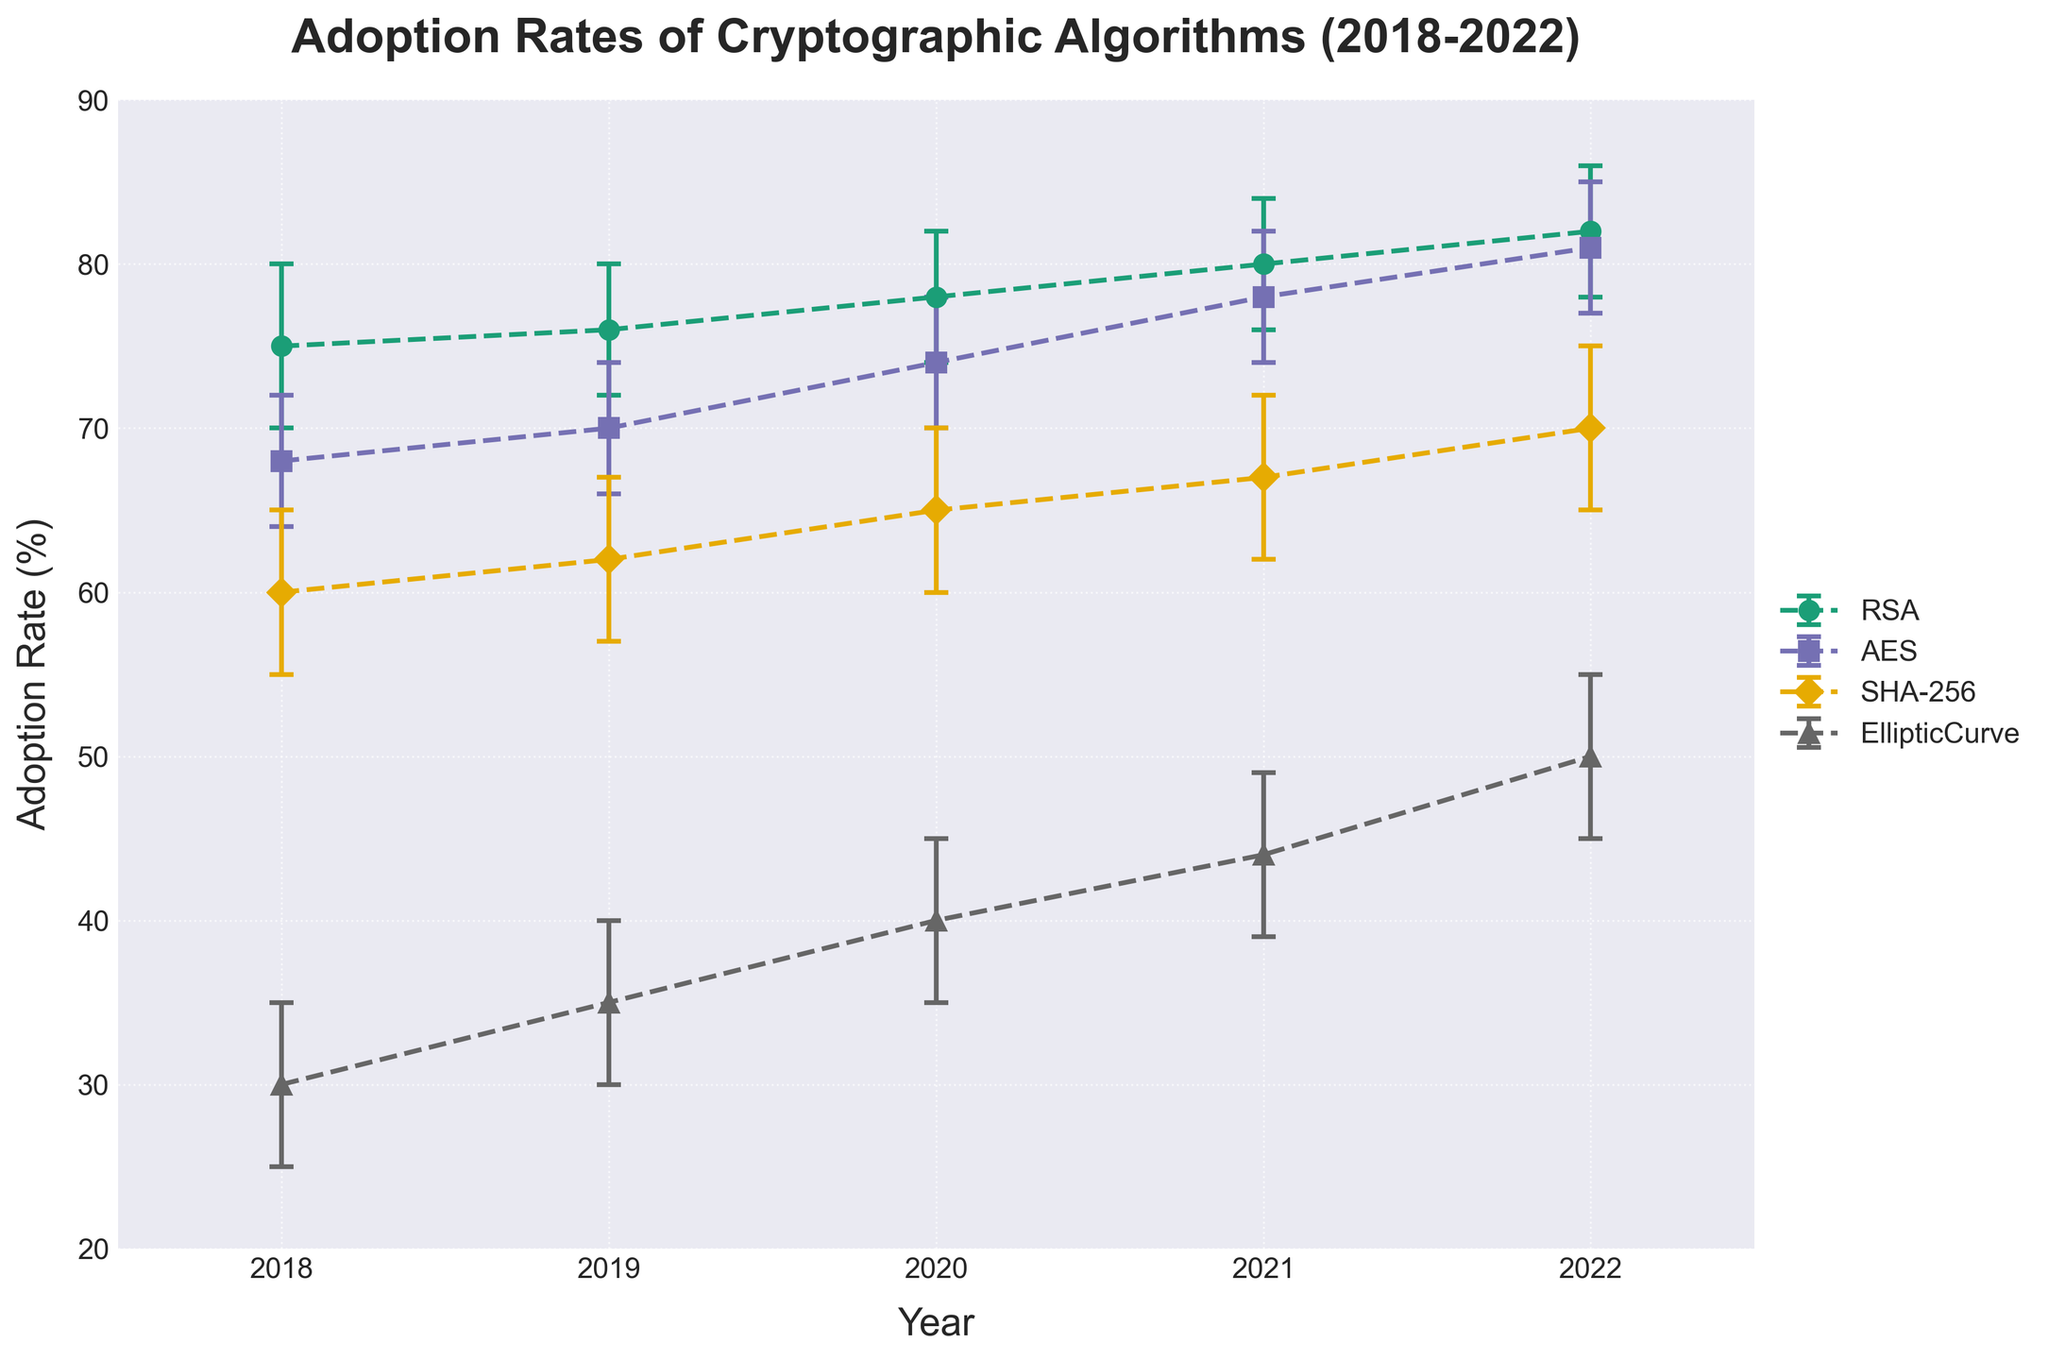What's the title of the plot? The title of the plot is usually displayed prominently at the top and it gives a summary of what the plot represents. In this case, it's "Adoption Rates of Cryptographic Algorithms (2018-2022)" as per the provided code.
Answer: Adoption Rates of Cryptographic Algorithms (2018-2022) What is the range of years shown on the x-axis? The x-axis represents the years in the dataset. It ranges from 2018 to 2022. This is visible from the provided data and code where the x-ticks are set.
Answer: 2018 to 2022 Which algorithm had the lowest adoption rate in 2018? By looking at the plot's data points for 2018, the lowest adoption rate is for the 'EllipticCurve' algorithm. This can be identified as the point appearing the lowest on the y-axis at the year 2018.
Answer: EllipticCurve How does the adoption rate of AES change from 2018 to 2022? To find this, you track the data points for AES from 2018 to 2022. The adoption rate increases from 68% in 2018 to 81% in 2022.
Answer: Increases Which algorithm shows the highest adoption rate in 2022 and what is its exact value? By examining the highest data point on the y-axis in 2022, the 'RSA' algorithm has the highest adoption rate at 82%.
Answer: RSA, 82% How many different algorithms are depicted in the plot? Each unique color and label in the legend represent a different algorithm. The provided data lists four algorithms: RSA, AES, SHA-256, and EllipticCurve.
Answer: 4 What is the confidence interval of the SHA-256 algorithm in 2022? The confidence interval for SHA-256 in 2022 can be identified by looking at the error bars. The CI_Lower is 65% and CI_Upper is 75%.
Answer: 65% to 75% Which year shows the closest adoption rates between RSA and AES? To identify this, visually compare the positions of RSA and AES for each year. In 2021, RSA has an adoption rate of 80% and AES has 78%, the closest in the dataset.
Answer: 2021 Calculate the average adoption rate for the EllipticCurve algorithm from 2018 to 2022. Add the adoption rates for EllipticCurve from 2018 to 2022 and divide by the number of years: (30 + 35 + 40 + 44 + 50) / 5 = 199 / 5 = 39.8%.
Answer: 39.8% 